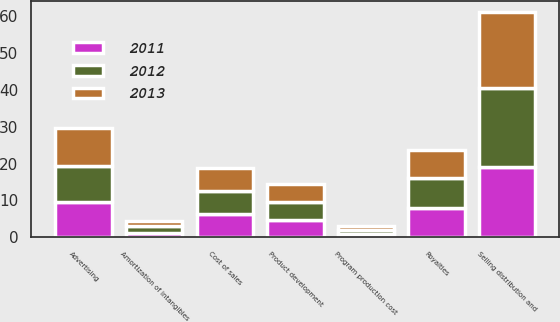Convert chart to OTSL. <chart><loc_0><loc_0><loc_500><loc_500><stacked_bar_chart><ecel><fcel>Cost of sales<fcel>Royalties<fcel>Product development<fcel>Advertising<fcel>Amortization of intangibles<fcel>Program production cost<fcel>Selling distribution and<nl><fcel>2012<fcel>6.25<fcel>8.3<fcel>5.1<fcel>9.8<fcel>1.9<fcel>1.2<fcel>21.3<nl><fcel>2013<fcel>6.25<fcel>7.4<fcel>4.9<fcel>10.3<fcel>1.3<fcel>1<fcel>20.7<nl><fcel>2011<fcel>6.25<fcel>7.9<fcel>4.6<fcel>9.7<fcel>1.1<fcel>0.8<fcel>19.2<nl></chart> 